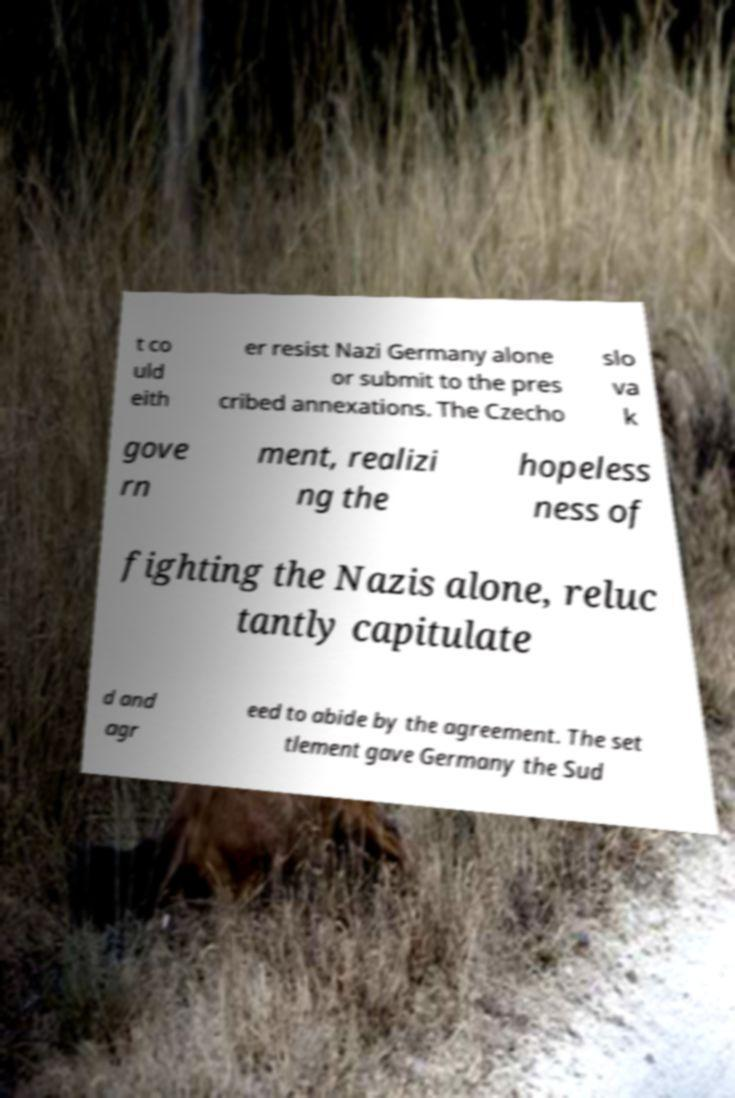Could you extract and type out the text from this image? t co uld eith er resist Nazi Germany alone or submit to the pres cribed annexations. The Czecho slo va k gove rn ment, realizi ng the hopeless ness of fighting the Nazis alone, reluc tantly capitulate d and agr eed to abide by the agreement. The set tlement gave Germany the Sud 